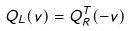Convert formula to latex. <formula><loc_0><loc_0><loc_500><loc_500>Q _ { L } ( v ) = Q ^ { T } _ { R } ( - v )</formula> 